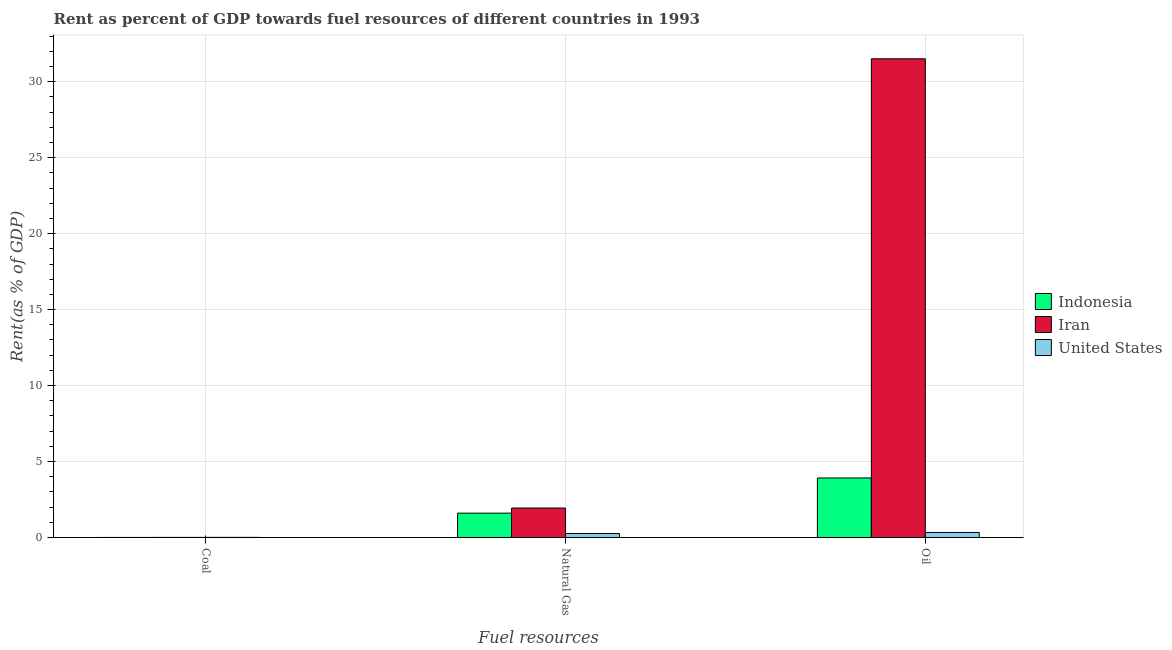How many different coloured bars are there?
Provide a succinct answer. 3. How many bars are there on the 3rd tick from the left?
Provide a short and direct response. 3. How many bars are there on the 1st tick from the right?
Your answer should be very brief. 3. What is the label of the 3rd group of bars from the left?
Give a very brief answer. Oil. What is the rent towards oil in United States?
Give a very brief answer. 0.33. Across all countries, what is the maximum rent towards coal?
Ensure brevity in your answer.  0.01. Across all countries, what is the minimum rent towards coal?
Make the answer very short. 0. In which country was the rent towards oil maximum?
Offer a terse response. Iran. What is the total rent towards oil in the graph?
Give a very brief answer. 35.75. What is the difference between the rent towards oil in United States and that in Iran?
Keep it short and to the point. -31.18. What is the difference between the rent towards coal in United States and the rent towards natural gas in Indonesia?
Make the answer very short. -1.6. What is the average rent towards oil per country?
Provide a succinct answer. 11.92. What is the difference between the rent towards natural gas and rent towards oil in Iran?
Offer a very short reply. -29.57. What is the ratio of the rent towards coal in Iran to that in Indonesia?
Provide a short and direct response. 2.46. Is the difference between the rent towards natural gas in Iran and Indonesia greater than the difference between the rent towards coal in Iran and Indonesia?
Provide a short and direct response. Yes. What is the difference between the highest and the second highest rent towards coal?
Offer a terse response. 0. What is the difference between the highest and the lowest rent towards natural gas?
Offer a terse response. 1.68. What does the 1st bar from the left in Coal represents?
Offer a very short reply. Indonesia. What does the 1st bar from the right in Coal represents?
Give a very brief answer. United States. How many bars are there?
Your response must be concise. 9. Are all the bars in the graph horizontal?
Offer a terse response. No. How many countries are there in the graph?
Ensure brevity in your answer.  3. What is the difference between two consecutive major ticks on the Y-axis?
Provide a succinct answer. 5. Does the graph contain any zero values?
Keep it short and to the point. No. Does the graph contain grids?
Offer a very short reply. Yes. Where does the legend appear in the graph?
Ensure brevity in your answer.  Center right. How many legend labels are there?
Provide a short and direct response. 3. What is the title of the graph?
Give a very brief answer. Rent as percent of GDP towards fuel resources of different countries in 1993. What is the label or title of the X-axis?
Your response must be concise. Fuel resources. What is the label or title of the Y-axis?
Ensure brevity in your answer.  Rent(as % of GDP). What is the Rent(as % of GDP) in Indonesia in Coal?
Ensure brevity in your answer.  0. What is the Rent(as % of GDP) in Iran in Coal?
Give a very brief answer. 0.01. What is the Rent(as % of GDP) in United States in Coal?
Provide a succinct answer. 0.01. What is the Rent(as % of GDP) of Indonesia in Natural Gas?
Offer a very short reply. 1.6. What is the Rent(as % of GDP) of Iran in Natural Gas?
Ensure brevity in your answer.  1.94. What is the Rent(as % of GDP) in United States in Natural Gas?
Your answer should be very brief. 0.26. What is the Rent(as % of GDP) of Indonesia in Oil?
Provide a succinct answer. 3.92. What is the Rent(as % of GDP) of Iran in Oil?
Offer a terse response. 31.51. What is the Rent(as % of GDP) of United States in Oil?
Keep it short and to the point. 0.33. Across all Fuel resources, what is the maximum Rent(as % of GDP) in Indonesia?
Make the answer very short. 3.92. Across all Fuel resources, what is the maximum Rent(as % of GDP) of Iran?
Your response must be concise. 31.51. Across all Fuel resources, what is the maximum Rent(as % of GDP) in United States?
Give a very brief answer. 0.33. Across all Fuel resources, what is the minimum Rent(as % of GDP) in Indonesia?
Ensure brevity in your answer.  0. Across all Fuel resources, what is the minimum Rent(as % of GDP) in Iran?
Your response must be concise. 0.01. Across all Fuel resources, what is the minimum Rent(as % of GDP) in United States?
Keep it short and to the point. 0.01. What is the total Rent(as % of GDP) in Indonesia in the graph?
Ensure brevity in your answer.  5.52. What is the total Rent(as % of GDP) in Iran in the graph?
Ensure brevity in your answer.  33.45. What is the total Rent(as % of GDP) in United States in the graph?
Offer a very short reply. 0.6. What is the difference between the Rent(as % of GDP) in Indonesia in Coal and that in Natural Gas?
Your response must be concise. -1.6. What is the difference between the Rent(as % of GDP) in Iran in Coal and that in Natural Gas?
Keep it short and to the point. -1.93. What is the difference between the Rent(as % of GDP) of United States in Coal and that in Natural Gas?
Your response must be concise. -0.25. What is the difference between the Rent(as % of GDP) of Indonesia in Coal and that in Oil?
Make the answer very short. -3.92. What is the difference between the Rent(as % of GDP) of Iran in Coal and that in Oil?
Your response must be concise. -31.5. What is the difference between the Rent(as % of GDP) in United States in Coal and that in Oil?
Give a very brief answer. -0.32. What is the difference between the Rent(as % of GDP) of Indonesia in Natural Gas and that in Oil?
Your answer should be very brief. -2.32. What is the difference between the Rent(as % of GDP) in Iran in Natural Gas and that in Oil?
Provide a succinct answer. -29.57. What is the difference between the Rent(as % of GDP) in United States in Natural Gas and that in Oil?
Provide a short and direct response. -0.07. What is the difference between the Rent(as % of GDP) in Indonesia in Coal and the Rent(as % of GDP) in Iran in Natural Gas?
Provide a short and direct response. -1.94. What is the difference between the Rent(as % of GDP) of Indonesia in Coal and the Rent(as % of GDP) of United States in Natural Gas?
Give a very brief answer. -0.26. What is the difference between the Rent(as % of GDP) of Iran in Coal and the Rent(as % of GDP) of United States in Natural Gas?
Your answer should be compact. -0.25. What is the difference between the Rent(as % of GDP) in Indonesia in Coal and the Rent(as % of GDP) in Iran in Oil?
Ensure brevity in your answer.  -31.5. What is the difference between the Rent(as % of GDP) of Indonesia in Coal and the Rent(as % of GDP) of United States in Oil?
Your response must be concise. -0.33. What is the difference between the Rent(as % of GDP) of Iran in Coal and the Rent(as % of GDP) of United States in Oil?
Give a very brief answer. -0.32. What is the difference between the Rent(as % of GDP) in Indonesia in Natural Gas and the Rent(as % of GDP) in Iran in Oil?
Provide a short and direct response. -29.9. What is the difference between the Rent(as % of GDP) of Indonesia in Natural Gas and the Rent(as % of GDP) of United States in Oil?
Offer a terse response. 1.27. What is the difference between the Rent(as % of GDP) of Iran in Natural Gas and the Rent(as % of GDP) of United States in Oil?
Ensure brevity in your answer.  1.61. What is the average Rent(as % of GDP) in Indonesia per Fuel resources?
Your answer should be very brief. 1.84. What is the average Rent(as % of GDP) of Iran per Fuel resources?
Provide a short and direct response. 11.15. What is the average Rent(as % of GDP) of United States per Fuel resources?
Keep it short and to the point. 0.2. What is the difference between the Rent(as % of GDP) in Indonesia and Rent(as % of GDP) in Iran in Coal?
Keep it short and to the point. -0. What is the difference between the Rent(as % of GDP) in Indonesia and Rent(as % of GDP) in United States in Coal?
Your answer should be very brief. -0. What is the difference between the Rent(as % of GDP) in Iran and Rent(as % of GDP) in United States in Coal?
Give a very brief answer. -0. What is the difference between the Rent(as % of GDP) in Indonesia and Rent(as % of GDP) in Iran in Natural Gas?
Your answer should be compact. -0.34. What is the difference between the Rent(as % of GDP) in Indonesia and Rent(as % of GDP) in United States in Natural Gas?
Give a very brief answer. 1.34. What is the difference between the Rent(as % of GDP) in Iran and Rent(as % of GDP) in United States in Natural Gas?
Offer a very short reply. 1.68. What is the difference between the Rent(as % of GDP) in Indonesia and Rent(as % of GDP) in Iran in Oil?
Make the answer very short. -27.59. What is the difference between the Rent(as % of GDP) of Indonesia and Rent(as % of GDP) of United States in Oil?
Provide a short and direct response. 3.59. What is the difference between the Rent(as % of GDP) of Iran and Rent(as % of GDP) of United States in Oil?
Your answer should be very brief. 31.18. What is the ratio of the Rent(as % of GDP) of Indonesia in Coal to that in Natural Gas?
Ensure brevity in your answer.  0. What is the ratio of the Rent(as % of GDP) in Iran in Coal to that in Natural Gas?
Give a very brief answer. 0. What is the ratio of the Rent(as % of GDP) of United States in Coal to that in Natural Gas?
Offer a very short reply. 0.03. What is the ratio of the Rent(as % of GDP) of Iran in Coal to that in Oil?
Your response must be concise. 0. What is the ratio of the Rent(as % of GDP) in United States in Coal to that in Oil?
Provide a succinct answer. 0.02. What is the ratio of the Rent(as % of GDP) in Indonesia in Natural Gas to that in Oil?
Keep it short and to the point. 0.41. What is the ratio of the Rent(as % of GDP) of Iran in Natural Gas to that in Oil?
Your answer should be very brief. 0.06. What is the ratio of the Rent(as % of GDP) in United States in Natural Gas to that in Oil?
Ensure brevity in your answer.  0.79. What is the difference between the highest and the second highest Rent(as % of GDP) in Indonesia?
Provide a succinct answer. 2.32. What is the difference between the highest and the second highest Rent(as % of GDP) in Iran?
Offer a very short reply. 29.57. What is the difference between the highest and the second highest Rent(as % of GDP) of United States?
Ensure brevity in your answer.  0.07. What is the difference between the highest and the lowest Rent(as % of GDP) in Indonesia?
Ensure brevity in your answer.  3.92. What is the difference between the highest and the lowest Rent(as % of GDP) in Iran?
Offer a terse response. 31.5. What is the difference between the highest and the lowest Rent(as % of GDP) in United States?
Offer a very short reply. 0.32. 